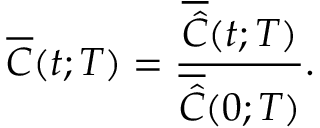Convert formula to latex. <formula><loc_0><loc_0><loc_500><loc_500>\overline { C } ( t ; T ) = \frac { \overline { { \hat { C } } } ( t ; T ) } { \overline { { \hat { C } } } ( 0 ; T ) } .</formula> 